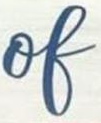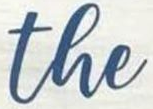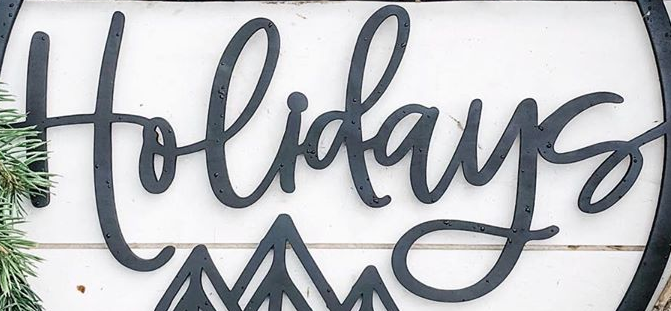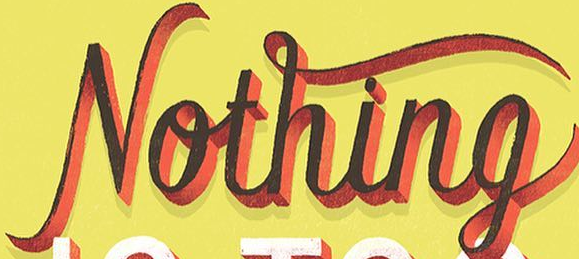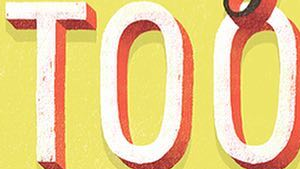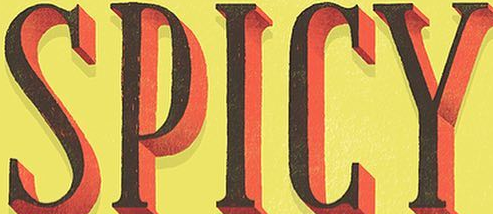What words are shown in these images in order, separated by a semicolon? of; the; Holidays; Nothing; TOO; SPICY 